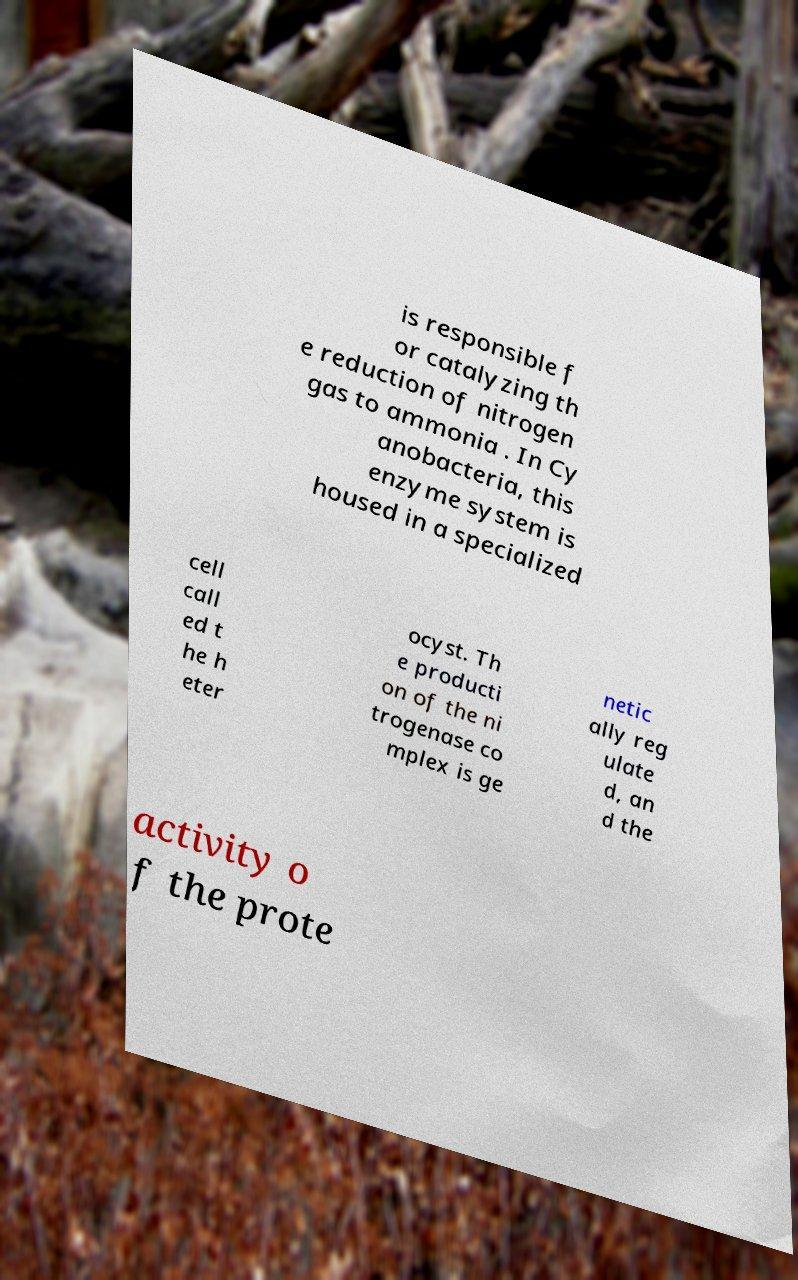What messages or text are displayed in this image? I need them in a readable, typed format. is responsible f or catalyzing th e reduction of nitrogen gas to ammonia . In Cy anobacteria, this enzyme system is housed in a specialized cell call ed t he h eter ocyst. Th e producti on of the ni trogenase co mplex is ge netic ally reg ulate d, an d the activity o f the prote 